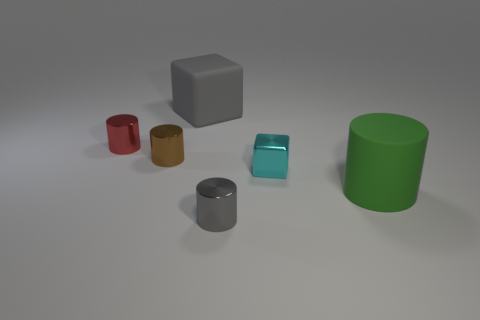Add 3 big blue objects. How many objects exist? 9 Subtract all cylinders. How many objects are left? 2 Add 4 tiny brown metal things. How many tiny brown metal things exist? 5 Subtract 0 cyan spheres. How many objects are left? 6 Subtract all rubber things. Subtract all large matte objects. How many objects are left? 2 Add 3 small gray shiny things. How many small gray shiny things are left? 4 